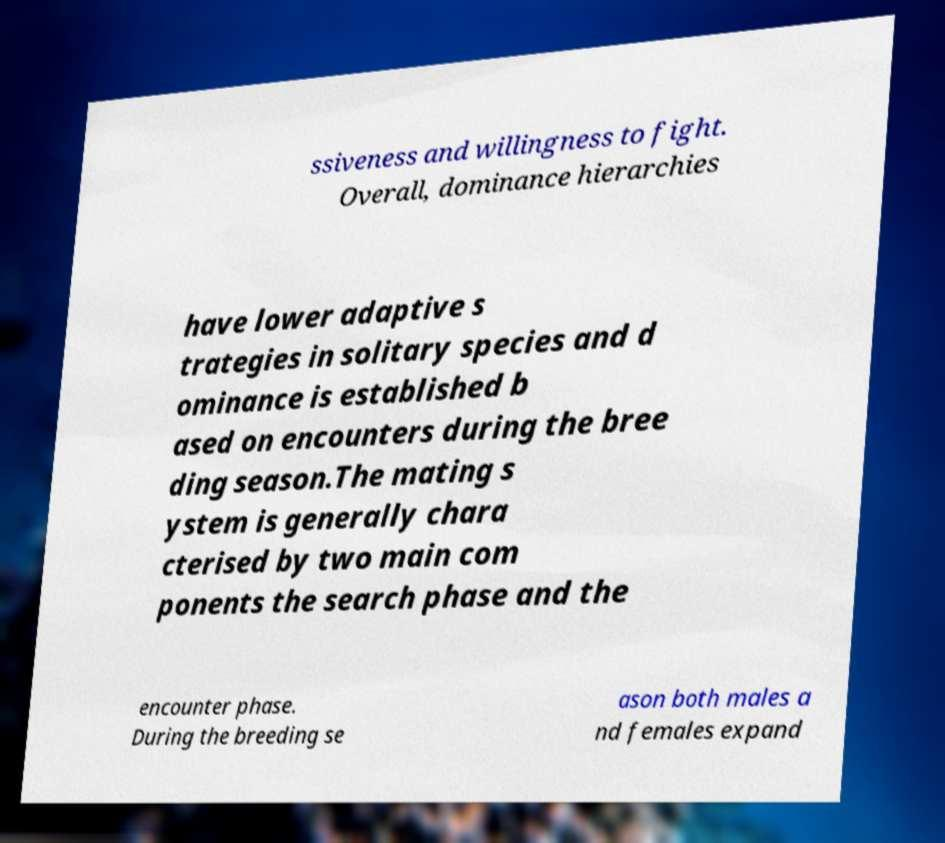Could you assist in decoding the text presented in this image and type it out clearly? ssiveness and willingness to fight. Overall, dominance hierarchies have lower adaptive s trategies in solitary species and d ominance is established b ased on encounters during the bree ding season.The mating s ystem is generally chara cterised by two main com ponents the search phase and the encounter phase. During the breeding se ason both males a nd females expand 